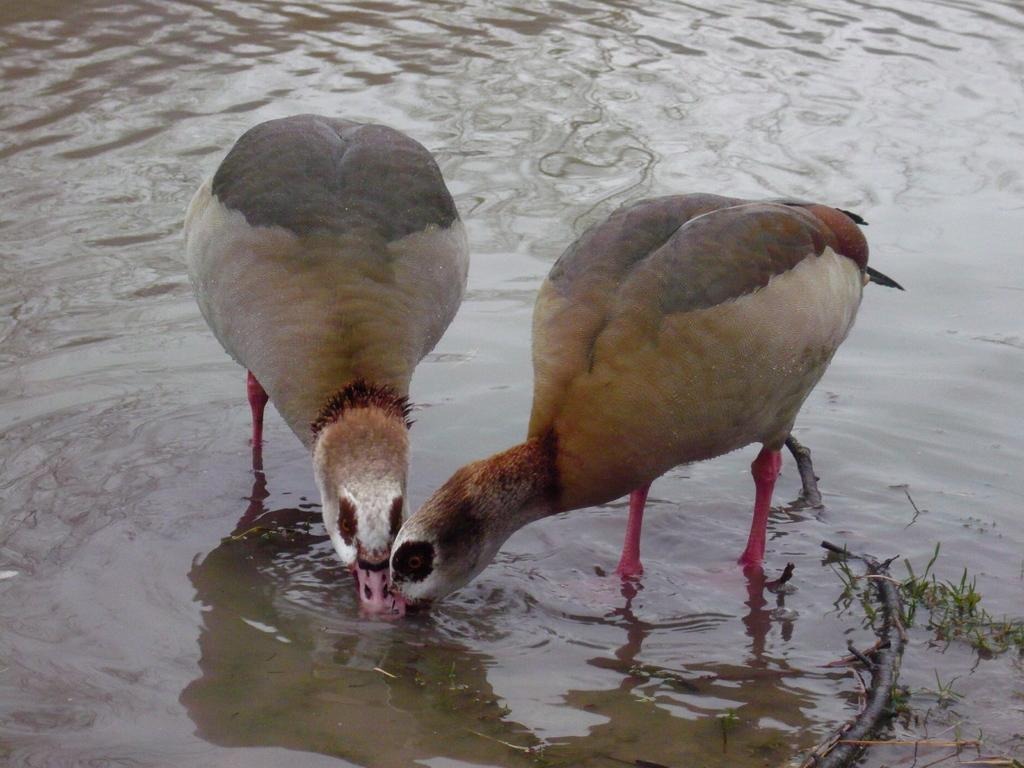What type of animals can be seen in the image? There are birds in the image. What are the birds doing in the image? The birds are standing and drinking water. What type of vegetation is on the right side of the image? There is grass on the right side of the image. What else can be seen in the image besides the birds and grass? There is a branch of a tree in the image. What type of joke is the bird telling in the image? There is no indication in the image that the bird is telling a joke, as it is simply standing and drinking water. 